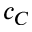<formula> <loc_0><loc_0><loc_500><loc_500>c _ { C }</formula> 